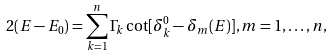<formula> <loc_0><loc_0><loc_500><loc_500>2 ( E - E _ { 0 } ) = \sum _ { k = 1 } ^ { n } \Gamma _ { k } \cot [ \delta _ { k } ^ { 0 } - \delta _ { m } ( E ) ] , m = 1 , \dots , n ,</formula> 